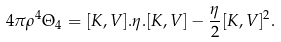<formula> <loc_0><loc_0><loc_500><loc_500>4 \pi \rho ^ { 4 } \Theta _ { 4 } = [ K , V ] . \eta . [ K , V ] - \frac { \eta } { 2 } [ K , V ] ^ { 2 } .</formula> 